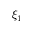<formula> <loc_0><loc_0><loc_500><loc_500>\xi _ { 1 }</formula> 